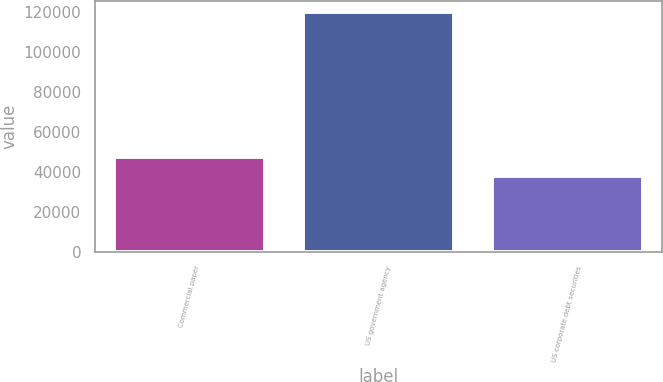Convert chart to OTSL. <chart><loc_0><loc_0><loc_500><loc_500><bar_chart><fcel>Commercial paper<fcel>US government agency<fcel>US corporate debt securities<nl><fcel>47687<fcel>119843<fcel>38103<nl></chart> 